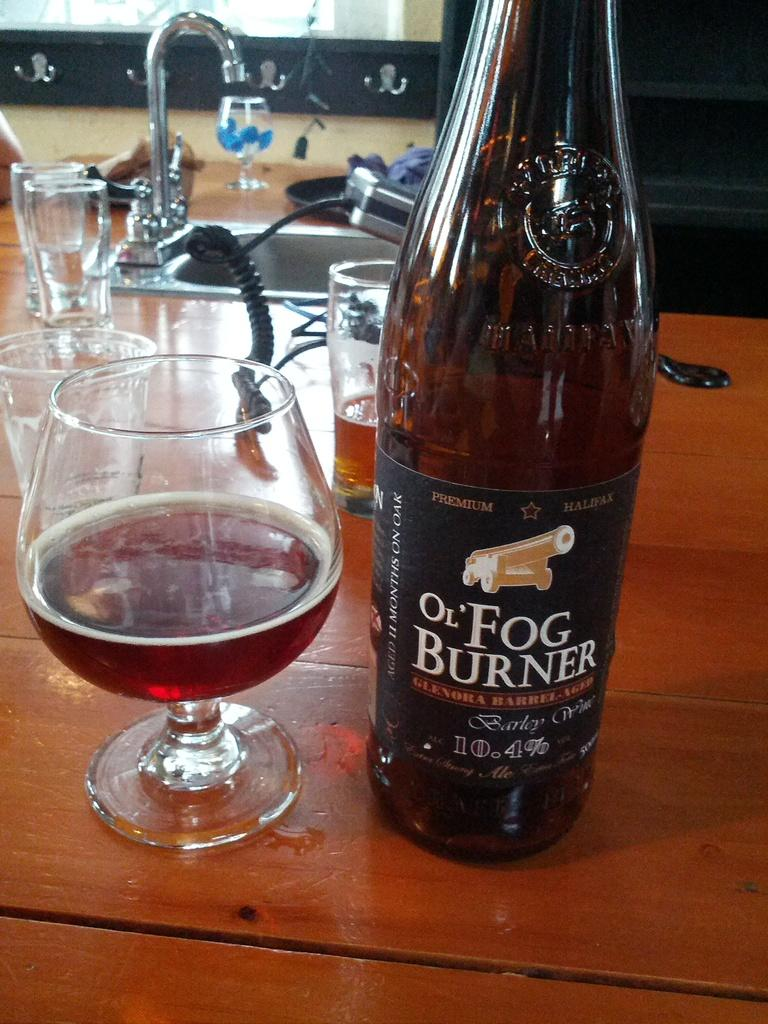What type of glassware is present in the image? There is a wine glass and a glass bottle in the image. Where are the wine glass and glass bottle located? They are on a wooden table in the image. What can be seen in the background of the image? There is a tap and a sink in the background of the image. What is the color of the tap and sink? The tap and sink are in silver color. How many ants are crawling on the wooden table in the image? There are no ants present in the image; it only features a wine glass, a glass bottle, and a wooden table. 